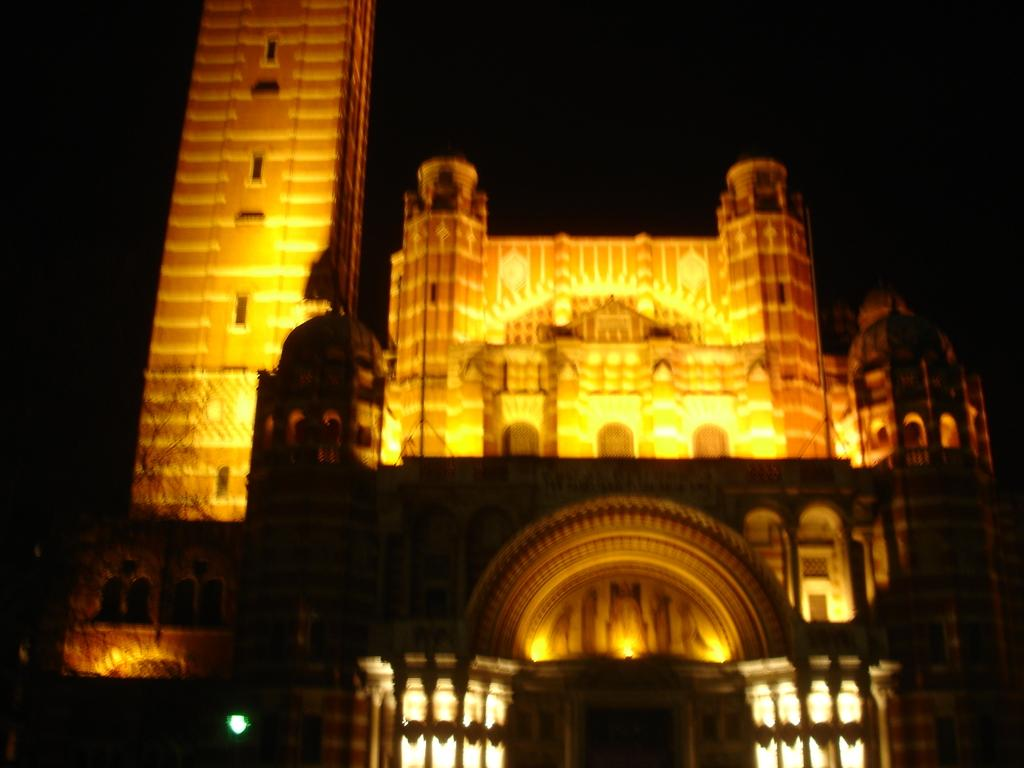What type of structure is present in the image? There is a building in the image. What specific feature can be seen on the building? The building has a tower. What can be seen illuminated in the image? There are lights visible in the image. What type of produce is being sold in the image? There is no produce present in the image; it features a building with a tower and lights. What type of cloth is draped over the tower in the image? There is no cloth draped over the tower in the image; it only has lights visible. 